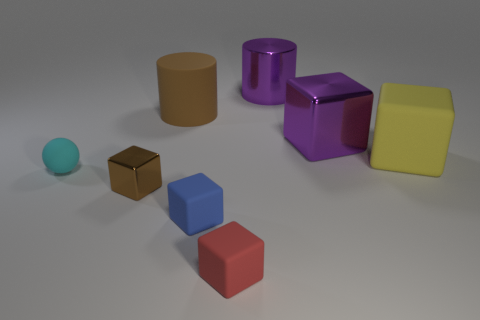Subtract all large purple shiny cubes. How many cubes are left? 4 Subtract all cyan cubes. Subtract all purple cylinders. How many cubes are left? 5 Add 1 big yellow objects. How many objects exist? 9 Subtract all balls. How many objects are left? 7 Add 6 brown shiny objects. How many brown shiny objects are left? 7 Add 6 small cyan rubber spheres. How many small cyan rubber spheres exist? 7 Subtract 0 gray cubes. How many objects are left? 8 Subtract all tiny red things. Subtract all yellow matte cubes. How many objects are left? 6 